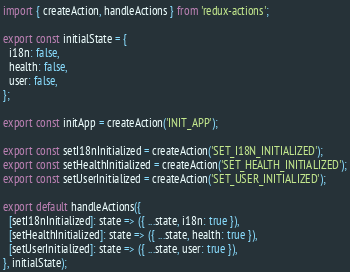Convert code to text. <code><loc_0><loc_0><loc_500><loc_500><_JavaScript_>import { createAction, handleActions } from 'redux-actions';

export const initialState = {
  i18n: false,
  health: false,
  user: false,
};

export const initApp = createAction('INIT_APP');

export const setI18nInitialized = createAction('SET_I18N_INITIALIZED');
export const setHealthInitialized = createAction('SET_HEALTH_INITIALIZED');
export const setUserInitialized = createAction('SET_USER_INITIALIZED');

export default handleActions({
  [setI18nInitialized]: state => ({ ...state, i18n: true }),
  [setHealthInitialized]: state => ({ ...state, health: true }),
  [setUserInitialized]: state => ({ ...state, user: true }),
}, initialState);
</code> 